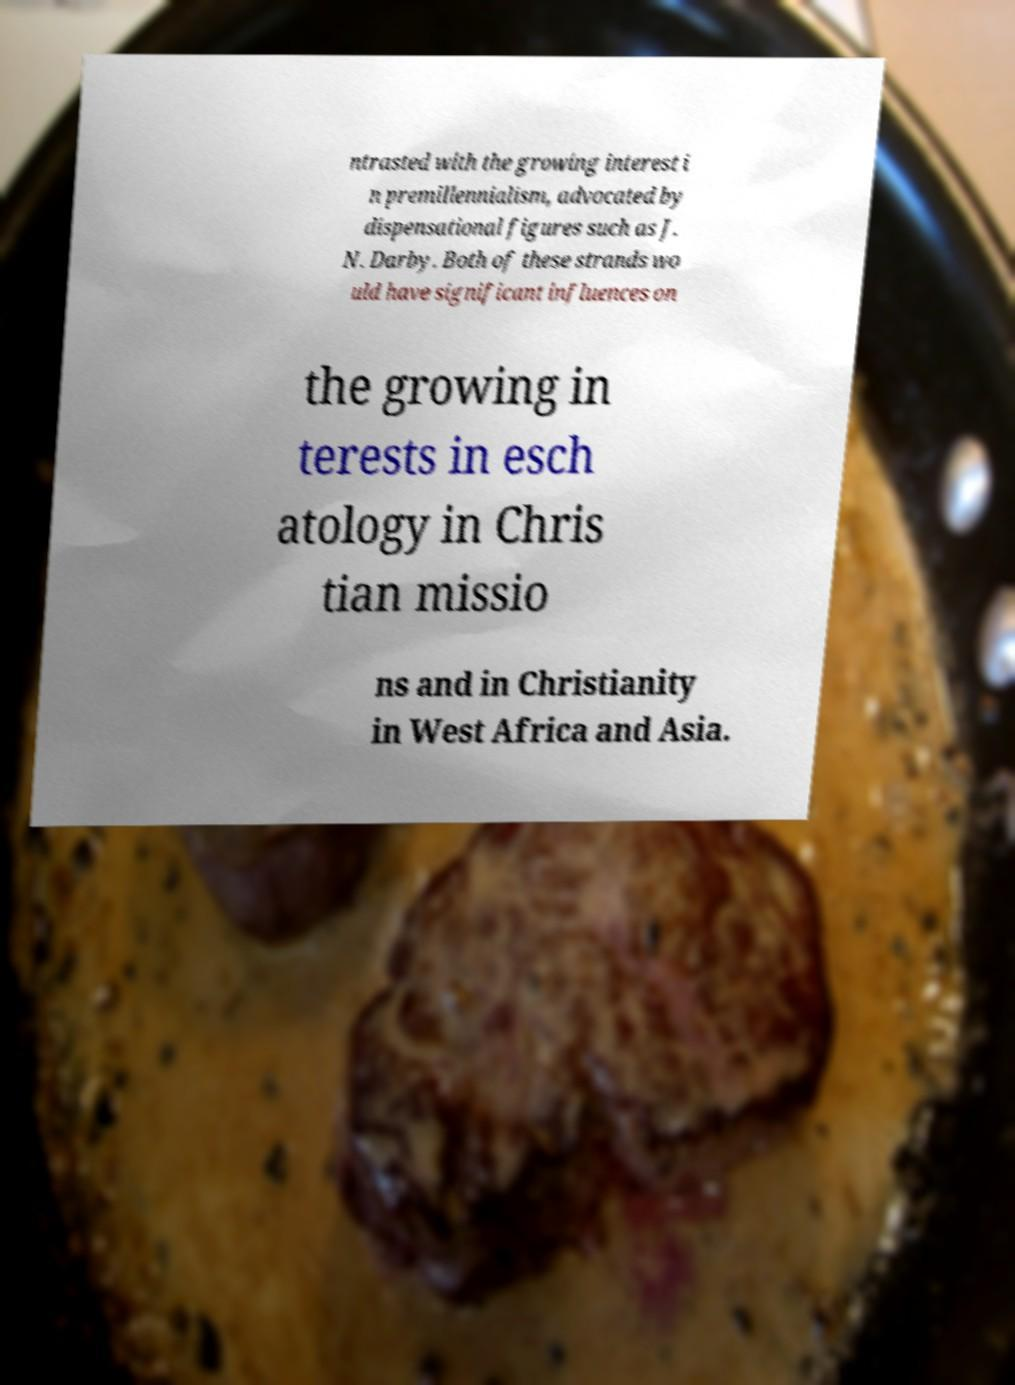Please read and relay the text visible in this image. What does it say? ntrasted with the growing interest i n premillennialism, advocated by dispensational figures such as J. N. Darby. Both of these strands wo uld have significant influences on the growing in terests in esch atology in Chris tian missio ns and in Christianity in West Africa and Asia. 